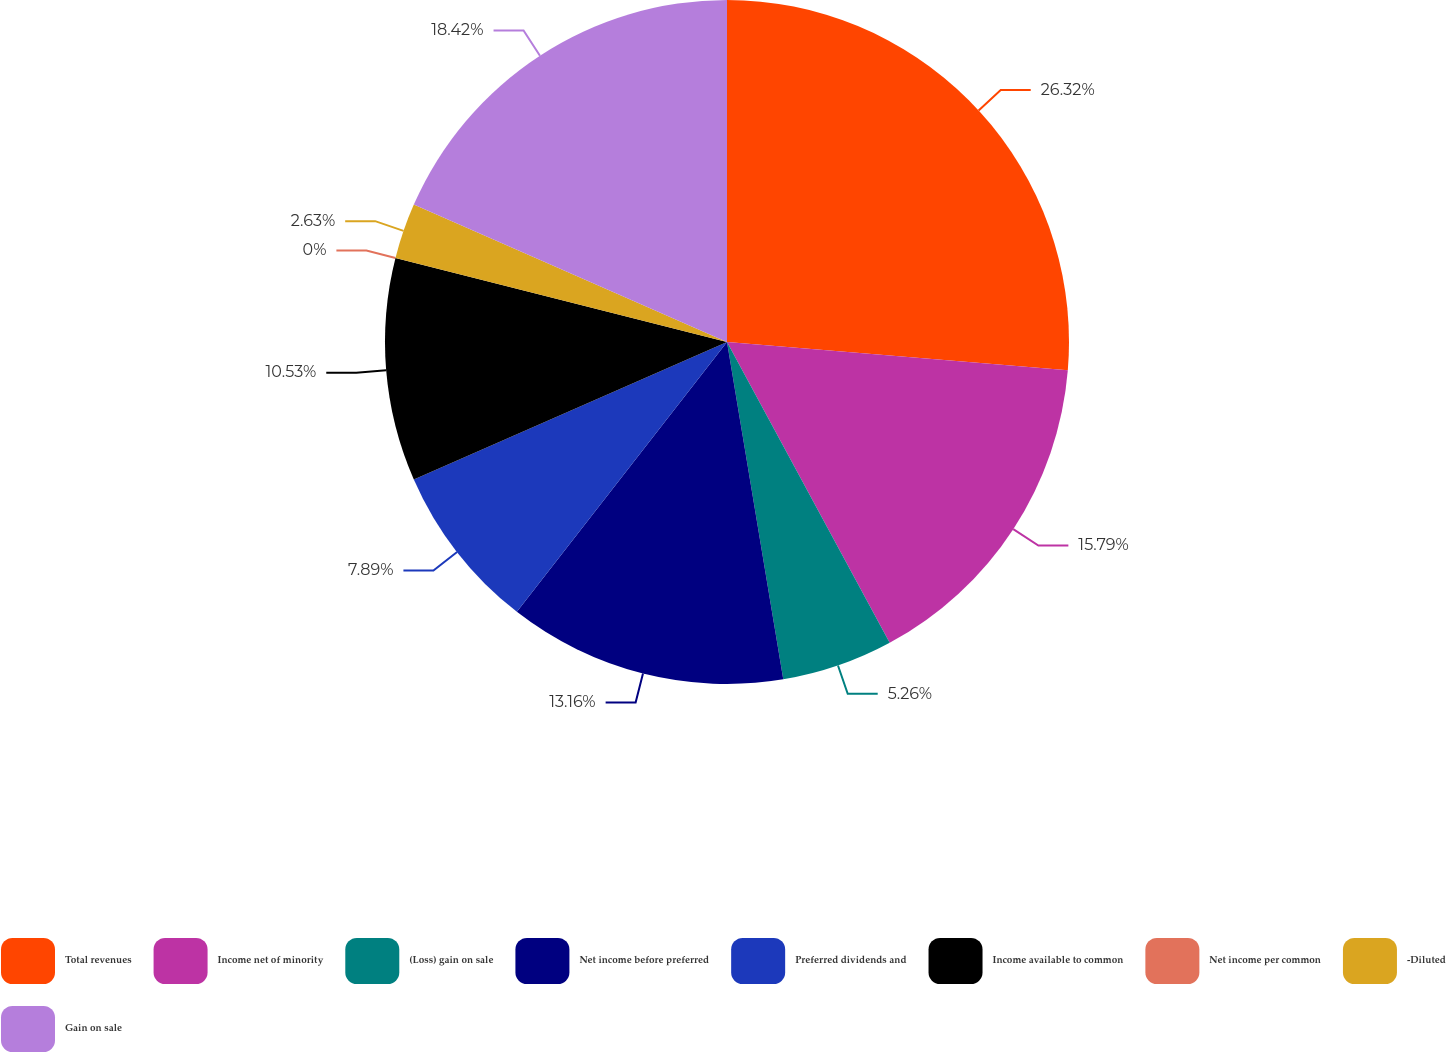Convert chart. <chart><loc_0><loc_0><loc_500><loc_500><pie_chart><fcel>Total revenues<fcel>Income net of minority<fcel>(Loss) gain on sale<fcel>Net income before preferred<fcel>Preferred dividends and<fcel>Income available to common<fcel>Net income per common<fcel>-Diluted<fcel>Gain on sale<nl><fcel>26.32%<fcel>15.79%<fcel>5.26%<fcel>13.16%<fcel>7.89%<fcel>10.53%<fcel>0.0%<fcel>2.63%<fcel>18.42%<nl></chart> 